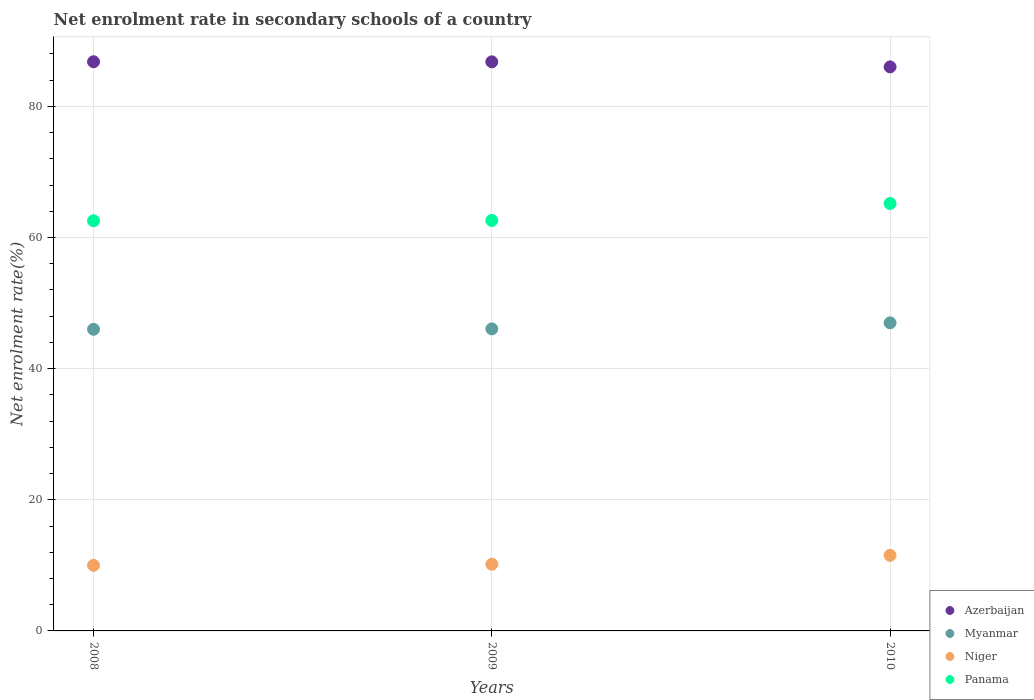Is the number of dotlines equal to the number of legend labels?
Ensure brevity in your answer.  Yes. What is the net enrolment rate in secondary schools in Panama in 2010?
Provide a short and direct response. 65.19. Across all years, what is the maximum net enrolment rate in secondary schools in Azerbaijan?
Give a very brief answer. 86.81. Across all years, what is the minimum net enrolment rate in secondary schools in Niger?
Your response must be concise. 10. In which year was the net enrolment rate in secondary schools in Azerbaijan maximum?
Ensure brevity in your answer.  2008. What is the total net enrolment rate in secondary schools in Myanmar in the graph?
Give a very brief answer. 139.06. What is the difference between the net enrolment rate in secondary schools in Myanmar in 2009 and that in 2010?
Your answer should be compact. -0.92. What is the difference between the net enrolment rate in secondary schools in Myanmar in 2010 and the net enrolment rate in secondary schools in Azerbaijan in 2008?
Your response must be concise. -39.82. What is the average net enrolment rate in secondary schools in Niger per year?
Provide a short and direct response. 10.57. In the year 2008, what is the difference between the net enrolment rate in secondary schools in Azerbaijan and net enrolment rate in secondary schools in Panama?
Keep it short and to the point. 24.26. In how many years, is the net enrolment rate in secondary schools in Myanmar greater than 72 %?
Offer a very short reply. 0. What is the ratio of the net enrolment rate in secondary schools in Myanmar in 2009 to that in 2010?
Provide a short and direct response. 0.98. Is the net enrolment rate in secondary schools in Myanmar in 2008 less than that in 2010?
Your answer should be very brief. Yes. Is the difference between the net enrolment rate in secondary schools in Azerbaijan in 2008 and 2010 greater than the difference between the net enrolment rate in secondary schools in Panama in 2008 and 2010?
Your answer should be very brief. Yes. What is the difference between the highest and the second highest net enrolment rate in secondary schools in Azerbaijan?
Your answer should be compact. 0.01. What is the difference between the highest and the lowest net enrolment rate in secondary schools in Myanmar?
Your answer should be very brief. 0.98. Is the sum of the net enrolment rate in secondary schools in Niger in 2008 and 2010 greater than the maximum net enrolment rate in secondary schools in Azerbaijan across all years?
Your answer should be very brief. No. Is it the case that in every year, the sum of the net enrolment rate in secondary schools in Panama and net enrolment rate in secondary schools in Azerbaijan  is greater than the sum of net enrolment rate in secondary schools in Myanmar and net enrolment rate in secondary schools in Niger?
Make the answer very short. Yes. Is it the case that in every year, the sum of the net enrolment rate in secondary schools in Myanmar and net enrolment rate in secondary schools in Niger  is greater than the net enrolment rate in secondary schools in Panama?
Keep it short and to the point. No. Is the net enrolment rate in secondary schools in Myanmar strictly less than the net enrolment rate in secondary schools in Niger over the years?
Offer a terse response. No. How many dotlines are there?
Offer a very short reply. 4. What is the difference between two consecutive major ticks on the Y-axis?
Offer a very short reply. 20. Are the values on the major ticks of Y-axis written in scientific E-notation?
Make the answer very short. No. Does the graph contain any zero values?
Your answer should be very brief. No. Does the graph contain grids?
Give a very brief answer. Yes. Where does the legend appear in the graph?
Make the answer very short. Bottom right. What is the title of the graph?
Give a very brief answer. Net enrolment rate in secondary schools of a country. What is the label or title of the X-axis?
Make the answer very short. Years. What is the label or title of the Y-axis?
Offer a very short reply. Net enrolment rate(%). What is the Net enrolment rate(%) in Azerbaijan in 2008?
Your response must be concise. 86.81. What is the Net enrolment rate(%) in Myanmar in 2008?
Your response must be concise. 46.01. What is the Net enrolment rate(%) in Niger in 2008?
Your answer should be very brief. 10. What is the Net enrolment rate(%) in Panama in 2008?
Provide a succinct answer. 62.55. What is the Net enrolment rate(%) of Azerbaijan in 2009?
Provide a succinct answer. 86.8. What is the Net enrolment rate(%) of Myanmar in 2009?
Keep it short and to the point. 46.06. What is the Net enrolment rate(%) of Niger in 2009?
Provide a short and direct response. 10.17. What is the Net enrolment rate(%) in Panama in 2009?
Provide a short and direct response. 62.6. What is the Net enrolment rate(%) of Azerbaijan in 2010?
Your response must be concise. 86.03. What is the Net enrolment rate(%) of Myanmar in 2010?
Your answer should be compact. 46.99. What is the Net enrolment rate(%) in Niger in 2010?
Your answer should be compact. 11.52. What is the Net enrolment rate(%) in Panama in 2010?
Your response must be concise. 65.19. Across all years, what is the maximum Net enrolment rate(%) of Azerbaijan?
Your response must be concise. 86.81. Across all years, what is the maximum Net enrolment rate(%) of Myanmar?
Offer a very short reply. 46.99. Across all years, what is the maximum Net enrolment rate(%) of Niger?
Offer a terse response. 11.52. Across all years, what is the maximum Net enrolment rate(%) in Panama?
Keep it short and to the point. 65.19. Across all years, what is the minimum Net enrolment rate(%) of Azerbaijan?
Ensure brevity in your answer.  86.03. Across all years, what is the minimum Net enrolment rate(%) of Myanmar?
Your answer should be compact. 46.01. Across all years, what is the minimum Net enrolment rate(%) in Niger?
Your answer should be very brief. 10. Across all years, what is the minimum Net enrolment rate(%) of Panama?
Your response must be concise. 62.55. What is the total Net enrolment rate(%) of Azerbaijan in the graph?
Provide a short and direct response. 259.64. What is the total Net enrolment rate(%) in Myanmar in the graph?
Your response must be concise. 139.06. What is the total Net enrolment rate(%) in Niger in the graph?
Your answer should be very brief. 31.7. What is the total Net enrolment rate(%) in Panama in the graph?
Make the answer very short. 190.35. What is the difference between the Net enrolment rate(%) in Azerbaijan in 2008 and that in 2009?
Give a very brief answer. 0.01. What is the difference between the Net enrolment rate(%) of Myanmar in 2008 and that in 2009?
Offer a very short reply. -0.06. What is the difference between the Net enrolment rate(%) of Niger in 2008 and that in 2009?
Keep it short and to the point. -0.17. What is the difference between the Net enrolment rate(%) of Panama in 2008 and that in 2009?
Provide a succinct answer. -0.05. What is the difference between the Net enrolment rate(%) of Azerbaijan in 2008 and that in 2010?
Provide a succinct answer. 0.78. What is the difference between the Net enrolment rate(%) of Myanmar in 2008 and that in 2010?
Make the answer very short. -0.98. What is the difference between the Net enrolment rate(%) in Niger in 2008 and that in 2010?
Provide a short and direct response. -1.52. What is the difference between the Net enrolment rate(%) of Panama in 2008 and that in 2010?
Make the answer very short. -2.64. What is the difference between the Net enrolment rate(%) of Azerbaijan in 2009 and that in 2010?
Your answer should be very brief. 0.77. What is the difference between the Net enrolment rate(%) of Myanmar in 2009 and that in 2010?
Offer a terse response. -0.92. What is the difference between the Net enrolment rate(%) in Niger in 2009 and that in 2010?
Make the answer very short. -1.35. What is the difference between the Net enrolment rate(%) of Panama in 2009 and that in 2010?
Offer a very short reply. -2.59. What is the difference between the Net enrolment rate(%) in Azerbaijan in 2008 and the Net enrolment rate(%) in Myanmar in 2009?
Offer a very short reply. 40.75. What is the difference between the Net enrolment rate(%) in Azerbaijan in 2008 and the Net enrolment rate(%) in Niger in 2009?
Your answer should be compact. 76.64. What is the difference between the Net enrolment rate(%) of Azerbaijan in 2008 and the Net enrolment rate(%) of Panama in 2009?
Your response must be concise. 24.21. What is the difference between the Net enrolment rate(%) of Myanmar in 2008 and the Net enrolment rate(%) of Niger in 2009?
Keep it short and to the point. 35.84. What is the difference between the Net enrolment rate(%) of Myanmar in 2008 and the Net enrolment rate(%) of Panama in 2009?
Offer a very short reply. -16.59. What is the difference between the Net enrolment rate(%) of Niger in 2008 and the Net enrolment rate(%) of Panama in 2009?
Offer a very short reply. -52.6. What is the difference between the Net enrolment rate(%) of Azerbaijan in 2008 and the Net enrolment rate(%) of Myanmar in 2010?
Your answer should be compact. 39.82. What is the difference between the Net enrolment rate(%) of Azerbaijan in 2008 and the Net enrolment rate(%) of Niger in 2010?
Provide a succinct answer. 75.29. What is the difference between the Net enrolment rate(%) in Azerbaijan in 2008 and the Net enrolment rate(%) in Panama in 2010?
Offer a terse response. 21.62. What is the difference between the Net enrolment rate(%) in Myanmar in 2008 and the Net enrolment rate(%) in Niger in 2010?
Provide a short and direct response. 34.48. What is the difference between the Net enrolment rate(%) of Myanmar in 2008 and the Net enrolment rate(%) of Panama in 2010?
Your answer should be compact. -19.18. What is the difference between the Net enrolment rate(%) of Niger in 2008 and the Net enrolment rate(%) of Panama in 2010?
Provide a succinct answer. -55.19. What is the difference between the Net enrolment rate(%) of Azerbaijan in 2009 and the Net enrolment rate(%) of Myanmar in 2010?
Provide a short and direct response. 39.81. What is the difference between the Net enrolment rate(%) of Azerbaijan in 2009 and the Net enrolment rate(%) of Niger in 2010?
Your response must be concise. 75.27. What is the difference between the Net enrolment rate(%) in Azerbaijan in 2009 and the Net enrolment rate(%) in Panama in 2010?
Keep it short and to the point. 21.61. What is the difference between the Net enrolment rate(%) in Myanmar in 2009 and the Net enrolment rate(%) in Niger in 2010?
Make the answer very short. 34.54. What is the difference between the Net enrolment rate(%) in Myanmar in 2009 and the Net enrolment rate(%) in Panama in 2010?
Your response must be concise. -19.13. What is the difference between the Net enrolment rate(%) in Niger in 2009 and the Net enrolment rate(%) in Panama in 2010?
Provide a succinct answer. -55.02. What is the average Net enrolment rate(%) in Azerbaijan per year?
Your response must be concise. 86.55. What is the average Net enrolment rate(%) of Myanmar per year?
Offer a terse response. 46.35. What is the average Net enrolment rate(%) of Niger per year?
Provide a succinct answer. 10.57. What is the average Net enrolment rate(%) in Panama per year?
Your response must be concise. 63.45. In the year 2008, what is the difference between the Net enrolment rate(%) in Azerbaijan and Net enrolment rate(%) in Myanmar?
Give a very brief answer. 40.8. In the year 2008, what is the difference between the Net enrolment rate(%) in Azerbaijan and Net enrolment rate(%) in Niger?
Offer a very short reply. 76.81. In the year 2008, what is the difference between the Net enrolment rate(%) of Azerbaijan and Net enrolment rate(%) of Panama?
Offer a terse response. 24.26. In the year 2008, what is the difference between the Net enrolment rate(%) of Myanmar and Net enrolment rate(%) of Niger?
Make the answer very short. 36.01. In the year 2008, what is the difference between the Net enrolment rate(%) of Myanmar and Net enrolment rate(%) of Panama?
Ensure brevity in your answer.  -16.54. In the year 2008, what is the difference between the Net enrolment rate(%) in Niger and Net enrolment rate(%) in Panama?
Your answer should be very brief. -52.55. In the year 2009, what is the difference between the Net enrolment rate(%) in Azerbaijan and Net enrolment rate(%) in Myanmar?
Your answer should be compact. 40.73. In the year 2009, what is the difference between the Net enrolment rate(%) in Azerbaijan and Net enrolment rate(%) in Niger?
Your answer should be very brief. 76.63. In the year 2009, what is the difference between the Net enrolment rate(%) in Azerbaijan and Net enrolment rate(%) in Panama?
Provide a short and direct response. 24.2. In the year 2009, what is the difference between the Net enrolment rate(%) of Myanmar and Net enrolment rate(%) of Niger?
Make the answer very short. 35.89. In the year 2009, what is the difference between the Net enrolment rate(%) in Myanmar and Net enrolment rate(%) in Panama?
Ensure brevity in your answer.  -16.54. In the year 2009, what is the difference between the Net enrolment rate(%) of Niger and Net enrolment rate(%) of Panama?
Offer a terse response. -52.43. In the year 2010, what is the difference between the Net enrolment rate(%) of Azerbaijan and Net enrolment rate(%) of Myanmar?
Provide a short and direct response. 39.04. In the year 2010, what is the difference between the Net enrolment rate(%) in Azerbaijan and Net enrolment rate(%) in Niger?
Ensure brevity in your answer.  74.5. In the year 2010, what is the difference between the Net enrolment rate(%) in Azerbaijan and Net enrolment rate(%) in Panama?
Your answer should be very brief. 20.83. In the year 2010, what is the difference between the Net enrolment rate(%) in Myanmar and Net enrolment rate(%) in Niger?
Your answer should be very brief. 35.46. In the year 2010, what is the difference between the Net enrolment rate(%) of Myanmar and Net enrolment rate(%) of Panama?
Your answer should be very brief. -18.2. In the year 2010, what is the difference between the Net enrolment rate(%) in Niger and Net enrolment rate(%) in Panama?
Make the answer very short. -53.67. What is the ratio of the Net enrolment rate(%) in Myanmar in 2008 to that in 2009?
Ensure brevity in your answer.  1. What is the ratio of the Net enrolment rate(%) of Niger in 2008 to that in 2009?
Ensure brevity in your answer.  0.98. What is the ratio of the Net enrolment rate(%) of Panama in 2008 to that in 2009?
Make the answer very short. 1. What is the ratio of the Net enrolment rate(%) in Azerbaijan in 2008 to that in 2010?
Offer a terse response. 1.01. What is the ratio of the Net enrolment rate(%) in Myanmar in 2008 to that in 2010?
Offer a very short reply. 0.98. What is the ratio of the Net enrolment rate(%) in Niger in 2008 to that in 2010?
Ensure brevity in your answer.  0.87. What is the ratio of the Net enrolment rate(%) of Panama in 2008 to that in 2010?
Make the answer very short. 0.96. What is the ratio of the Net enrolment rate(%) in Myanmar in 2009 to that in 2010?
Your response must be concise. 0.98. What is the ratio of the Net enrolment rate(%) of Niger in 2009 to that in 2010?
Offer a terse response. 0.88. What is the ratio of the Net enrolment rate(%) of Panama in 2009 to that in 2010?
Keep it short and to the point. 0.96. What is the difference between the highest and the second highest Net enrolment rate(%) of Azerbaijan?
Ensure brevity in your answer.  0.01. What is the difference between the highest and the second highest Net enrolment rate(%) in Myanmar?
Your answer should be compact. 0.92. What is the difference between the highest and the second highest Net enrolment rate(%) of Niger?
Offer a very short reply. 1.35. What is the difference between the highest and the second highest Net enrolment rate(%) of Panama?
Provide a succinct answer. 2.59. What is the difference between the highest and the lowest Net enrolment rate(%) of Azerbaijan?
Your answer should be compact. 0.78. What is the difference between the highest and the lowest Net enrolment rate(%) in Myanmar?
Give a very brief answer. 0.98. What is the difference between the highest and the lowest Net enrolment rate(%) of Niger?
Your answer should be very brief. 1.52. What is the difference between the highest and the lowest Net enrolment rate(%) of Panama?
Ensure brevity in your answer.  2.64. 